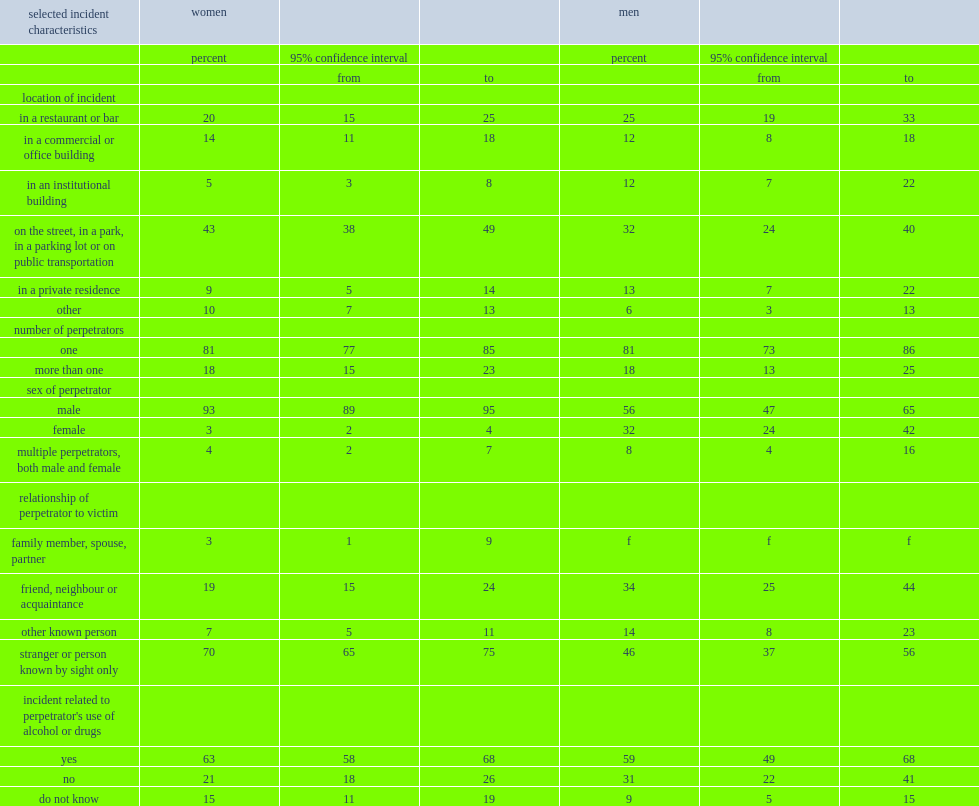What is the percentage of women who experienced unwanted sexual behaviour and indicated that the personnote behind the most serious behaviour was a man? 93.0. What is the percentage of men who experienced unwanted sexual behaviour in a public space and identified the perpetrator as a man? 56.0. Which gender group identified a friend, acquaintance or neighbour as the perpetrator of the most serious incident they experienced more often, men or women? Men. What is the percentage of women who had experienced at least one unwanted sexual behaviour in a public space and indicated that the person who initiated the most serious incident was a stranger? 70.0. What is the percentage of men who experienced unwanted sexual behaviour and were targeted by a stranger? 46.0. 